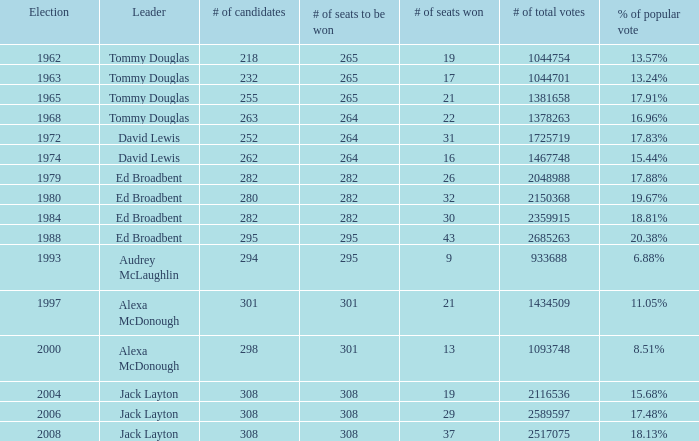What is the number of seats to be won when the percentage of popular vote is at 6.88%? 295.0. 